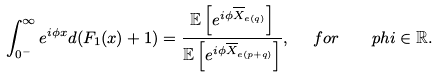<formula> <loc_0><loc_0><loc_500><loc_500>\int _ { 0 ^ { - } } ^ { \infty } e ^ { i \phi x } d ( F _ { 1 } ( x ) + 1 ) = \frac { \mathbb { E } \left [ e ^ { i \phi \overline { X } _ { e ( q ) } } \right ] } { \mathbb { E } \left [ e ^ { i \phi \overline { X } _ { e ( p + q ) } } \right ] } , \ \ f o r \quad p h i \in \mathbb { R } .</formula> 